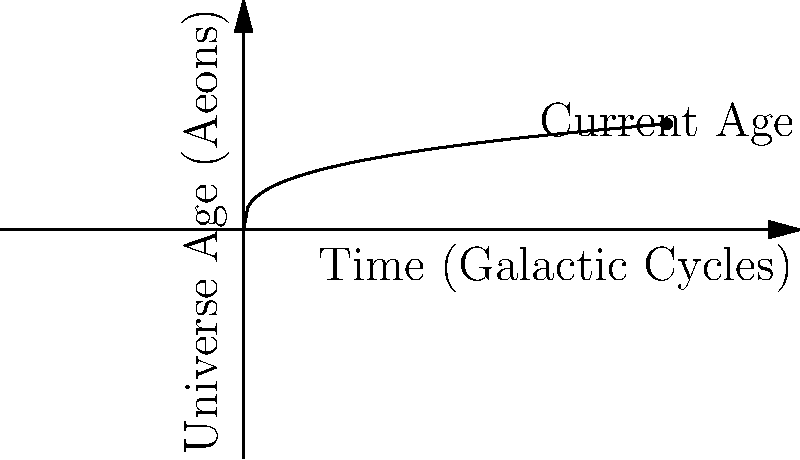In the Zorgon time-keeping system, the age of the universe is measured in Aeons, while time progresses in Galactic Cycles. The relationship between these units is given by the equation $A = G^{\frac{1}{3}}$, where $A$ is the age in Aeons and $G$ is the number of Galactic Cycles. If the current age of the universe is 2 Aeons, how many Galactic Cycles have passed? To solve this problem, we need to follow these steps:

1) We are given the equation: $A = G^{\frac{1}{3}}$

2) We know the current age of the universe is 2 Aeons, so we substitute $A = 2$:

   $2 = G^{\frac{1}{3}}$

3) To isolate $G$, we need to cube both sides of the equation:

   $(2)^3 = (G^{\frac{1}{3}})^3$

4) Simplify:

   $8 = G$

5) Therefore, 8 Galactic Cycles have passed.

This problem demonstrates the use of an unconventional number system in astronomical calculations, aligning with the persona of an educator who encourages exploring such systems.
Answer: 8 Galactic Cycles 